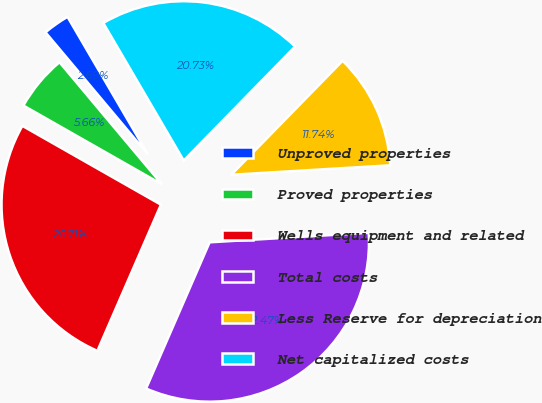<chart> <loc_0><loc_0><loc_500><loc_500><pie_chart><fcel>Unproved properties<fcel>Proved properties<fcel>Wells equipment and related<fcel>Total costs<fcel>Less Reserve for depreciation<fcel>Net capitalized costs<nl><fcel>2.69%<fcel>5.66%<fcel>26.71%<fcel>32.47%<fcel>11.74%<fcel>20.73%<nl></chart> 